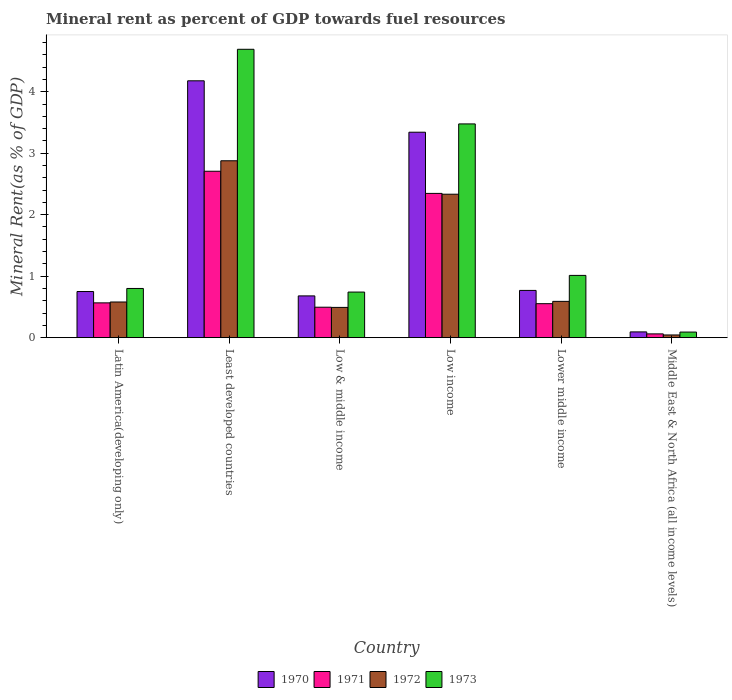How many bars are there on the 1st tick from the right?
Your answer should be very brief. 4. What is the label of the 2nd group of bars from the left?
Ensure brevity in your answer.  Least developed countries. In how many cases, is the number of bars for a given country not equal to the number of legend labels?
Your answer should be very brief. 0. What is the mineral rent in 1970 in Least developed countries?
Provide a succinct answer. 4.18. Across all countries, what is the maximum mineral rent in 1973?
Ensure brevity in your answer.  4.69. Across all countries, what is the minimum mineral rent in 1973?
Give a very brief answer. 0.09. In which country was the mineral rent in 1971 maximum?
Provide a short and direct response. Least developed countries. In which country was the mineral rent in 1973 minimum?
Keep it short and to the point. Middle East & North Africa (all income levels). What is the total mineral rent in 1971 in the graph?
Offer a terse response. 6.73. What is the difference between the mineral rent in 1972 in Low & middle income and that in Lower middle income?
Your answer should be very brief. -0.1. What is the difference between the mineral rent in 1971 in Least developed countries and the mineral rent in 1970 in Low income?
Ensure brevity in your answer.  -0.63. What is the average mineral rent in 1972 per country?
Give a very brief answer. 1.15. What is the difference between the mineral rent of/in 1970 and mineral rent of/in 1971 in Lower middle income?
Give a very brief answer. 0.22. In how many countries, is the mineral rent in 1971 greater than 1.2 %?
Your response must be concise. 2. What is the ratio of the mineral rent in 1972 in Low & middle income to that in Middle East & North Africa (all income levels)?
Offer a very short reply. 11.19. Is the mineral rent in 1973 in Low income less than that in Middle East & North Africa (all income levels)?
Give a very brief answer. No. What is the difference between the highest and the second highest mineral rent in 1970?
Give a very brief answer. -2.57. What is the difference between the highest and the lowest mineral rent in 1970?
Your answer should be compact. 4.08. Are all the bars in the graph horizontal?
Offer a very short reply. No. Are the values on the major ticks of Y-axis written in scientific E-notation?
Your answer should be compact. No. Does the graph contain any zero values?
Your answer should be very brief. No. What is the title of the graph?
Provide a short and direct response. Mineral rent as percent of GDP towards fuel resources. What is the label or title of the X-axis?
Your answer should be compact. Country. What is the label or title of the Y-axis?
Give a very brief answer. Mineral Rent(as % of GDP). What is the Mineral Rent(as % of GDP) of 1970 in Latin America(developing only)?
Give a very brief answer. 0.75. What is the Mineral Rent(as % of GDP) in 1971 in Latin America(developing only)?
Your response must be concise. 0.57. What is the Mineral Rent(as % of GDP) of 1972 in Latin America(developing only)?
Offer a terse response. 0.58. What is the Mineral Rent(as % of GDP) in 1973 in Latin America(developing only)?
Keep it short and to the point. 0.8. What is the Mineral Rent(as % of GDP) in 1970 in Least developed countries?
Give a very brief answer. 4.18. What is the Mineral Rent(as % of GDP) of 1971 in Least developed countries?
Keep it short and to the point. 2.71. What is the Mineral Rent(as % of GDP) of 1972 in Least developed countries?
Offer a terse response. 2.88. What is the Mineral Rent(as % of GDP) of 1973 in Least developed countries?
Make the answer very short. 4.69. What is the Mineral Rent(as % of GDP) of 1970 in Low & middle income?
Offer a terse response. 0.68. What is the Mineral Rent(as % of GDP) of 1971 in Low & middle income?
Your answer should be compact. 0.5. What is the Mineral Rent(as % of GDP) of 1972 in Low & middle income?
Your response must be concise. 0.49. What is the Mineral Rent(as % of GDP) of 1973 in Low & middle income?
Keep it short and to the point. 0.74. What is the Mineral Rent(as % of GDP) in 1970 in Low income?
Make the answer very short. 3.34. What is the Mineral Rent(as % of GDP) of 1971 in Low income?
Keep it short and to the point. 2.35. What is the Mineral Rent(as % of GDP) of 1972 in Low income?
Offer a terse response. 2.33. What is the Mineral Rent(as % of GDP) in 1973 in Low income?
Your answer should be very brief. 3.48. What is the Mineral Rent(as % of GDP) of 1970 in Lower middle income?
Make the answer very short. 0.77. What is the Mineral Rent(as % of GDP) of 1971 in Lower middle income?
Your answer should be compact. 0.55. What is the Mineral Rent(as % of GDP) in 1972 in Lower middle income?
Offer a very short reply. 0.59. What is the Mineral Rent(as % of GDP) in 1973 in Lower middle income?
Make the answer very short. 1.01. What is the Mineral Rent(as % of GDP) of 1970 in Middle East & North Africa (all income levels)?
Ensure brevity in your answer.  0.09. What is the Mineral Rent(as % of GDP) in 1971 in Middle East & North Africa (all income levels)?
Ensure brevity in your answer.  0.06. What is the Mineral Rent(as % of GDP) in 1972 in Middle East & North Africa (all income levels)?
Your answer should be compact. 0.04. What is the Mineral Rent(as % of GDP) of 1973 in Middle East & North Africa (all income levels)?
Keep it short and to the point. 0.09. Across all countries, what is the maximum Mineral Rent(as % of GDP) of 1970?
Offer a very short reply. 4.18. Across all countries, what is the maximum Mineral Rent(as % of GDP) in 1971?
Give a very brief answer. 2.71. Across all countries, what is the maximum Mineral Rent(as % of GDP) in 1972?
Offer a very short reply. 2.88. Across all countries, what is the maximum Mineral Rent(as % of GDP) in 1973?
Your response must be concise. 4.69. Across all countries, what is the minimum Mineral Rent(as % of GDP) of 1970?
Your answer should be very brief. 0.09. Across all countries, what is the minimum Mineral Rent(as % of GDP) of 1971?
Make the answer very short. 0.06. Across all countries, what is the minimum Mineral Rent(as % of GDP) of 1972?
Offer a terse response. 0.04. Across all countries, what is the minimum Mineral Rent(as % of GDP) in 1973?
Your answer should be very brief. 0.09. What is the total Mineral Rent(as % of GDP) of 1970 in the graph?
Make the answer very short. 9.81. What is the total Mineral Rent(as % of GDP) in 1971 in the graph?
Your answer should be compact. 6.73. What is the total Mineral Rent(as % of GDP) in 1972 in the graph?
Your answer should be compact. 6.92. What is the total Mineral Rent(as % of GDP) of 1973 in the graph?
Give a very brief answer. 10.81. What is the difference between the Mineral Rent(as % of GDP) in 1970 in Latin America(developing only) and that in Least developed countries?
Make the answer very short. -3.43. What is the difference between the Mineral Rent(as % of GDP) of 1971 in Latin America(developing only) and that in Least developed countries?
Make the answer very short. -2.14. What is the difference between the Mineral Rent(as % of GDP) of 1972 in Latin America(developing only) and that in Least developed countries?
Make the answer very short. -2.3. What is the difference between the Mineral Rent(as % of GDP) in 1973 in Latin America(developing only) and that in Least developed countries?
Give a very brief answer. -3.89. What is the difference between the Mineral Rent(as % of GDP) of 1970 in Latin America(developing only) and that in Low & middle income?
Ensure brevity in your answer.  0.07. What is the difference between the Mineral Rent(as % of GDP) of 1971 in Latin America(developing only) and that in Low & middle income?
Keep it short and to the point. 0.07. What is the difference between the Mineral Rent(as % of GDP) in 1972 in Latin America(developing only) and that in Low & middle income?
Offer a terse response. 0.09. What is the difference between the Mineral Rent(as % of GDP) of 1973 in Latin America(developing only) and that in Low & middle income?
Give a very brief answer. 0.06. What is the difference between the Mineral Rent(as % of GDP) of 1970 in Latin America(developing only) and that in Low income?
Provide a succinct answer. -2.59. What is the difference between the Mineral Rent(as % of GDP) of 1971 in Latin America(developing only) and that in Low income?
Give a very brief answer. -1.78. What is the difference between the Mineral Rent(as % of GDP) of 1972 in Latin America(developing only) and that in Low income?
Offer a very short reply. -1.75. What is the difference between the Mineral Rent(as % of GDP) of 1973 in Latin America(developing only) and that in Low income?
Provide a short and direct response. -2.68. What is the difference between the Mineral Rent(as % of GDP) in 1970 in Latin America(developing only) and that in Lower middle income?
Your response must be concise. -0.02. What is the difference between the Mineral Rent(as % of GDP) in 1971 in Latin America(developing only) and that in Lower middle income?
Your answer should be compact. 0.01. What is the difference between the Mineral Rent(as % of GDP) in 1972 in Latin America(developing only) and that in Lower middle income?
Provide a short and direct response. -0.01. What is the difference between the Mineral Rent(as % of GDP) of 1973 in Latin America(developing only) and that in Lower middle income?
Make the answer very short. -0.21. What is the difference between the Mineral Rent(as % of GDP) of 1970 in Latin America(developing only) and that in Middle East & North Africa (all income levels)?
Provide a short and direct response. 0.66. What is the difference between the Mineral Rent(as % of GDP) in 1971 in Latin America(developing only) and that in Middle East & North Africa (all income levels)?
Keep it short and to the point. 0.5. What is the difference between the Mineral Rent(as % of GDP) in 1972 in Latin America(developing only) and that in Middle East & North Africa (all income levels)?
Provide a short and direct response. 0.54. What is the difference between the Mineral Rent(as % of GDP) of 1973 in Latin America(developing only) and that in Middle East & North Africa (all income levels)?
Your response must be concise. 0.71. What is the difference between the Mineral Rent(as % of GDP) of 1970 in Least developed countries and that in Low & middle income?
Offer a terse response. 3.5. What is the difference between the Mineral Rent(as % of GDP) in 1971 in Least developed countries and that in Low & middle income?
Offer a very short reply. 2.21. What is the difference between the Mineral Rent(as % of GDP) of 1972 in Least developed countries and that in Low & middle income?
Offer a very short reply. 2.38. What is the difference between the Mineral Rent(as % of GDP) of 1973 in Least developed countries and that in Low & middle income?
Make the answer very short. 3.95. What is the difference between the Mineral Rent(as % of GDP) of 1970 in Least developed countries and that in Low income?
Your answer should be compact. 0.84. What is the difference between the Mineral Rent(as % of GDP) in 1971 in Least developed countries and that in Low income?
Your answer should be compact. 0.36. What is the difference between the Mineral Rent(as % of GDP) of 1972 in Least developed countries and that in Low income?
Provide a succinct answer. 0.54. What is the difference between the Mineral Rent(as % of GDP) in 1973 in Least developed countries and that in Low income?
Provide a short and direct response. 1.21. What is the difference between the Mineral Rent(as % of GDP) in 1970 in Least developed countries and that in Lower middle income?
Ensure brevity in your answer.  3.41. What is the difference between the Mineral Rent(as % of GDP) in 1971 in Least developed countries and that in Lower middle income?
Ensure brevity in your answer.  2.15. What is the difference between the Mineral Rent(as % of GDP) of 1972 in Least developed countries and that in Lower middle income?
Offer a terse response. 2.29. What is the difference between the Mineral Rent(as % of GDP) of 1973 in Least developed countries and that in Lower middle income?
Keep it short and to the point. 3.68. What is the difference between the Mineral Rent(as % of GDP) in 1970 in Least developed countries and that in Middle East & North Africa (all income levels)?
Provide a short and direct response. 4.08. What is the difference between the Mineral Rent(as % of GDP) in 1971 in Least developed countries and that in Middle East & North Africa (all income levels)?
Your answer should be very brief. 2.65. What is the difference between the Mineral Rent(as % of GDP) in 1972 in Least developed countries and that in Middle East & North Africa (all income levels)?
Offer a terse response. 2.83. What is the difference between the Mineral Rent(as % of GDP) of 1973 in Least developed countries and that in Middle East & North Africa (all income levels)?
Make the answer very short. 4.6. What is the difference between the Mineral Rent(as % of GDP) in 1970 in Low & middle income and that in Low income?
Make the answer very short. -2.66. What is the difference between the Mineral Rent(as % of GDP) in 1971 in Low & middle income and that in Low income?
Your response must be concise. -1.85. What is the difference between the Mineral Rent(as % of GDP) of 1972 in Low & middle income and that in Low income?
Your response must be concise. -1.84. What is the difference between the Mineral Rent(as % of GDP) in 1973 in Low & middle income and that in Low income?
Make the answer very short. -2.73. What is the difference between the Mineral Rent(as % of GDP) of 1970 in Low & middle income and that in Lower middle income?
Offer a terse response. -0.09. What is the difference between the Mineral Rent(as % of GDP) in 1971 in Low & middle income and that in Lower middle income?
Ensure brevity in your answer.  -0.06. What is the difference between the Mineral Rent(as % of GDP) in 1972 in Low & middle income and that in Lower middle income?
Your answer should be very brief. -0.1. What is the difference between the Mineral Rent(as % of GDP) of 1973 in Low & middle income and that in Lower middle income?
Make the answer very short. -0.27. What is the difference between the Mineral Rent(as % of GDP) in 1970 in Low & middle income and that in Middle East & North Africa (all income levels)?
Make the answer very short. 0.59. What is the difference between the Mineral Rent(as % of GDP) of 1971 in Low & middle income and that in Middle East & North Africa (all income levels)?
Ensure brevity in your answer.  0.43. What is the difference between the Mineral Rent(as % of GDP) of 1972 in Low & middle income and that in Middle East & North Africa (all income levels)?
Ensure brevity in your answer.  0.45. What is the difference between the Mineral Rent(as % of GDP) in 1973 in Low & middle income and that in Middle East & North Africa (all income levels)?
Your answer should be very brief. 0.65. What is the difference between the Mineral Rent(as % of GDP) of 1970 in Low income and that in Lower middle income?
Your response must be concise. 2.57. What is the difference between the Mineral Rent(as % of GDP) of 1971 in Low income and that in Lower middle income?
Provide a succinct answer. 1.79. What is the difference between the Mineral Rent(as % of GDP) of 1972 in Low income and that in Lower middle income?
Offer a very short reply. 1.74. What is the difference between the Mineral Rent(as % of GDP) in 1973 in Low income and that in Lower middle income?
Make the answer very short. 2.46. What is the difference between the Mineral Rent(as % of GDP) of 1970 in Low income and that in Middle East & North Africa (all income levels)?
Provide a succinct answer. 3.25. What is the difference between the Mineral Rent(as % of GDP) in 1971 in Low income and that in Middle East & North Africa (all income levels)?
Give a very brief answer. 2.28. What is the difference between the Mineral Rent(as % of GDP) in 1972 in Low income and that in Middle East & North Africa (all income levels)?
Your response must be concise. 2.29. What is the difference between the Mineral Rent(as % of GDP) of 1973 in Low income and that in Middle East & North Africa (all income levels)?
Offer a terse response. 3.39. What is the difference between the Mineral Rent(as % of GDP) in 1970 in Lower middle income and that in Middle East & North Africa (all income levels)?
Keep it short and to the point. 0.67. What is the difference between the Mineral Rent(as % of GDP) in 1971 in Lower middle income and that in Middle East & North Africa (all income levels)?
Your response must be concise. 0.49. What is the difference between the Mineral Rent(as % of GDP) of 1972 in Lower middle income and that in Middle East & North Africa (all income levels)?
Offer a very short reply. 0.55. What is the difference between the Mineral Rent(as % of GDP) of 1973 in Lower middle income and that in Middle East & North Africa (all income levels)?
Your response must be concise. 0.92. What is the difference between the Mineral Rent(as % of GDP) in 1970 in Latin America(developing only) and the Mineral Rent(as % of GDP) in 1971 in Least developed countries?
Offer a very short reply. -1.96. What is the difference between the Mineral Rent(as % of GDP) of 1970 in Latin America(developing only) and the Mineral Rent(as % of GDP) of 1972 in Least developed countries?
Keep it short and to the point. -2.13. What is the difference between the Mineral Rent(as % of GDP) in 1970 in Latin America(developing only) and the Mineral Rent(as % of GDP) in 1973 in Least developed countries?
Your answer should be very brief. -3.94. What is the difference between the Mineral Rent(as % of GDP) of 1971 in Latin America(developing only) and the Mineral Rent(as % of GDP) of 1972 in Least developed countries?
Your answer should be compact. -2.31. What is the difference between the Mineral Rent(as % of GDP) in 1971 in Latin America(developing only) and the Mineral Rent(as % of GDP) in 1973 in Least developed countries?
Ensure brevity in your answer.  -4.12. What is the difference between the Mineral Rent(as % of GDP) in 1972 in Latin America(developing only) and the Mineral Rent(as % of GDP) in 1973 in Least developed countries?
Your answer should be compact. -4.11. What is the difference between the Mineral Rent(as % of GDP) in 1970 in Latin America(developing only) and the Mineral Rent(as % of GDP) in 1971 in Low & middle income?
Ensure brevity in your answer.  0.26. What is the difference between the Mineral Rent(as % of GDP) in 1970 in Latin America(developing only) and the Mineral Rent(as % of GDP) in 1972 in Low & middle income?
Offer a terse response. 0.26. What is the difference between the Mineral Rent(as % of GDP) in 1970 in Latin America(developing only) and the Mineral Rent(as % of GDP) in 1973 in Low & middle income?
Provide a short and direct response. 0.01. What is the difference between the Mineral Rent(as % of GDP) in 1971 in Latin America(developing only) and the Mineral Rent(as % of GDP) in 1972 in Low & middle income?
Ensure brevity in your answer.  0.07. What is the difference between the Mineral Rent(as % of GDP) in 1971 in Latin America(developing only) and the Mineral Rent(as % of GDP) in 1973 in Low & middle income?
Ensure brevity in your answer.  -0.18. What is the difference between the Mineral Rent(as % of GDP) in 1972 in Latin America(developing only) and the Mineral Rent(as % of GDP) in 1973 in Low & middle income?
Your answer should be very brief. -0.16. What is the difference between the Mineral Rent(as % of GDP) in 1970 in Latin America(developing only) and the Mineral Rent(as % of GDP) in 1971 in Low income?
Offer a terse response. -1.6. What is the difference between the Mineral Rent(as % of GDP) in 1970 in Latin America(developing only) and the Mineral Rent(as % of GDP) in 1972 in Low income?
Ensure brevity in your answer.  -1.58. What is the difference between the Mineral Rent(as % of GDP) of 1970 in Latin America(developing only) and the Mineral Rent(as % of GDP) of 1973 in Low income?
Offer a terse response. -2.73. What is the difference between the Mineral Rent(as % of GDP) in 1971 in Latin America(developing only) and the Mineral Rent(as % of GDP) in 1972 in Low income?
Make the answer very short. -1.77. What is the difference between the Mineral Rent(as % of GDP) in 1971 in Latin America(developing only) and the Mineral Rent(as % of GDP) in 1973 in Low income?
Give a very brief answer. -2.91. What is the difference between the Mineral Rent(as % of GDP) of 1972 in Latin America(developing only) and the Mineral Rent(as % of GDP) of 1973 in Low income?
Make the answer very short. -2.9. What is the difference between the Mineral Rent(as % of GDP) of 1970 in Latin America(developing only) and the Mineral Rent(as % of GDP) of 1971 in Lower middle income?
Ensure brevity in your answer.  0.2. What is the difference between the Mineral Rent(as % of GDP) in 1970 in Latin America(developing only) and the Mineral Rent(as % of GDP) in 1972 in Lower middle income?
Provide a short and direct response. 0.16. What is the difference between the Mineral Rent(as % of GDP) in 1970 in Latin America(developing only) and the Mineral Rent(as % of GDP) in 1973 in Lower middle income?
Offer a terse response. -0.26. What is the difference between the Mineral Rent(as % of GDP) of 1971 in Latin America(developing only) and the Mineral Rent(as % of GDP) of 1972 in Lower middle income?
Give a very brief answer. -0.02. What is the difference between the Mineral Rent(as % of GDP) of 1971 in Latin America(developing only) and the Mineral Rent(as % of GDP) of 1973 in Lower middle income?
Ensure brevity in your answer.  -0.45. What is the difference between the Mineral Rent(as % of GDP) in 1972 in Latin America(developing only) and the Mineral Rent(as % of GDP) in 1973 in Lower middle income?
Ensure brevity in your answer.  -0.43. What is the difference between the Mineral Rent(as % of GDP) of 1970 in Latin America(developing only) and the Mineral Rent(as % of GDP) of 1971 in Middle East & North Africa (all income levels)?
Your answer should be very brief. 0.69. What is the difference between the Mineral Rent(as % of GDP) in 1970 in Latin America(developing only) and the Mineral Rent(as % of GDP) in 1972 in Middle East & North Africa (all income levels)?
Make the answer very short. 0.71. What is the difference between the Mineral Rent(as % of GDP) in 1970 in Latin America(developing only) and the Mineral Rent(as % of GDP) in 1973 in Middle East & North Africa (all income levels)?
Provide a short and direct response. 0.66. What is the difference between the Mineral Rent(as % of GDP) in 1971 in Latin America(developing only) and the Mineral Rent(as % of GDP) in 1972 in Middle East & North Africa (all income levels)?
Your response must be concise. 0.52. What is the difference between the Mineral Rent(as % of GDP) of 1971 in Latin America(developing only) and the Mineral Rent(as % of GDP) of 1973 in Middle East & North Africa (all income levels)?
Offer a terse response. 0.47. What is the difference between the Mineral Rent(as % of GDP) of 1972 in Latin America(developing only) and the Mineral Rent(as % of GDP) of 1973 in Middle East & North Africa (all income levels)?
Provide a succinct answer. 0.49. What is the difference between the Mineral Rent(as % of GDP) in 1970 in Least developed countries and the Mineral Rent(as % of GDP) in 1971 in Low & middle income?
Make the answer very short. 3.68. What is the difference between the Mineral Rent(as % of GDP) of 1970 in Least developed countries and the Mineral Rent(as % of GDP) of 1972 in Low & middle income?
Provide a succinct answer. 3.69. What is the difference between the Mineral Rent(as % of GDP) of 1970 in Least developed countries and the Mineral Rent(as % of GDP) of 1973 in Low & middle income?
Your answer should be very brief. 3.44. What is the difference between the Mineral Rent(as % of GDP) in 1971 in Least developed countries and the Mineral Rent(as % of GDP) in 1972 in Low & middle income?
Your answer should be very brief. 2.21. What is the difference between the Mineral Rent(as % of GDP) of 1971 in Least developed countries and the Mineral Rent(as % of GDP) of 1973 in Low & middle income?
Keep it short and to the point. 1.97. What is the difference between the Mineral Rent(as % of GDP) in 1972 in Least developed countries and the Mineral Rent(as % of GDP) in 1973 in Low & middle income?
Make the answer very short. 2.14. What is the difference between the Mineral Rent(as % of GDP) in 1970 in Least developed countries and the Mineral Rent(as % of GDP) in 1971 in Low income?
Offer a terse response. 1.83. What is the difference between the Mineral Rent(as % of GDP) of 1970 in Least developed countries and the Mineral Rent(as % of GDP) of 1972 in Low income?
Your answer should be very brief. 1.84. What is the difference between the Mineral Rent(as % of GDP) of 1970 in Least developed countries and the Mineral Rent(as % of GDP) of 1973 in Low income?
Make the answer very short. 0.7. What is the difference between the Mineral Rent(as % of GDP) in 1971 in Least developed countries and the Mineral Rent(as % of GDP) in 1972 in Low income?
Your response must be concise. 0.37. What is the difference between the Mineral Rent(as % of GDP) of 1971 in Least developed countries and the Mineral Rent(as % of GDP) of 1973 in Low income?
Your answer should be very brief. -0.77. What is the difference between the Mineral Rent(as % of GDP) of 1972 in Least developed countries and the Mineral Rent(as % of GDP) of 1973 in Low income?
Your answer should be very brief. -0.6. What is the difference between the Mineral Rent(as % of GDP) in 1970 in Least developed countries and the Mineral Rent(as % of GDP) in 1971 in Lower middle income?
Offer a terse response. 3.62. What is the difference between the Mineral Rent(as % of GDP) of 1970 in Least developed countries and the Mineral Rent(as % of GDP) of 1972 in Lower middle income?
Offer a very short reply. 3.59. What is the difference between the Mineral Rent(as % of GDP) in 1970 in Least developed countries and the Mineral Rent(as % of GDP) in 1973 in Lower middle income?
Make the answer very short. 3.16. What is the difference between the Mineral Rent(as % of GDP) in 1971 in Least developed countries and the Mineral Rent(as % of GDP) in 1972 in Lower middle income?
Keep it short and to the point. 2.12. What is the difference between the Mineral Rent(as % of GDP) of 1971 in Least developed countries and the Mineral Rent(as % of GDP) of 1973 in Lower middle income?
Offer a very short reply. 1.69. What is the difference between the Mineral Rent(as % of GDP) of 1972 in Least developed countries and the Mineral Rent(as % of GDP) of 1973 in Lower middle income?
Provide a succinct answer. 1.86. What is the difference between the Mineral Rent(as % of GDP) of 1970 in Least developed countries and the Mineral Rent(as % of GDP) of 1971 in Middle East & North Africa (all income levels)?
Offer a very short reply. 4.12. What is the difference between the Mineral Rent(as % of GDP) in 1970 in Least developed countries and the Mineral Rent(as % of GDP) in 1972 in Middle East & North Africa (all income levels)?
Provide a succinct answer. 4.13. What is the difference between the Mineral Rent(as % of GDP) in 1970 in Least developed countries and the Mineral Rent(as % of GDP) in 1973 in Middle East & North Africa (all income levels)?
Provide a short and direct response. 4.09. What is the difference between the Mineral Rent(as % of GDP) of 1971 in Least developed countries and the Mineral Rent(as % of GDP) of 1972 in Middle East & North Africa (all income levels)?
Your response must be concise. 2.66. What is the difference between the Mineral Rent(as % of GDP) in 1971 in Least developed countries and the Mineral Rent(as % of GDP) in 1973 in Middle East & North Africa (all income levels)?
Ensure brevity in your answer.  2.62. What is the difference between the Mineral Rent(as % of GDP) in 1972 in Least developed countries and the Mineral Rent(as % of GDP) in 1973 in Middle East & North Africa (all income levels)?
Offer a terse response. 2.79. What is the difference between the Mineral Rent(as % of GDP) in 1970 in Low & middle income and the Mineral Rent(as % of GDP) in 1971 in Low income?
Make the answer very short. -1.67. What is the difference between the Mineral Rent(as % of GDP) of 1970 in Low & middle income and the Mineral Rent(as % of GDP) of 1972 in Low income?
Give a very brief answer. -1.65. What is the difference between the Mineral Rent(as % of GDP) in 1970 in Low & middle income and the Mineral Rent(as % of GDP) in 1973 in Low income?
Ensure brevity in your answer.  -2.8. What is the difference between the Mineral Rent(as % of GDP) in 1971 in Low & middle income and the Mineral Rent(as % of GDP) in 1972 in Low income?
Your response must be concise. -1.84. What is the difference between the Mineral Rent(as % of GDP) in 1971 in Low & middle income and the Mineral Rent(as % of GDP) in 1973 in Low income?
Provide a succinct answer. -2.98. What is the difference between the Mineral Rent(as % of GDP) in 1972 in Low & middle income and the Mineral Rent(as % of GDP) in 1973 in Low income?
Keep it short and to the point. -2.98. What is the difference between the Mineral Rent(as % of GDP) of 1970 in Low & middle income and the Mineral Rent(as % of GDP) of 1971 in Lower middle income?
Provide a succinct answer. 0.13. What is the difference between the Mineral Rent(as % of GDP) in 1970 in Low & middle income and the Mineral Rent(as % of GDP) in 1972 in Lower middle income?
Provide a short and direct response. 0.09. What is the difference between the Mineral Rent(as % of GDP) in 1970 in Low & middle income and the Mineral Rent(as % of GDP) in 1973 in Lower middle income?
Your answer should be very brief. -0.33. What is the difference between the Mineral Rent(as % of GDP) of 1971 in Low & middle income and the Mineral Rent(as % of GDP) of 1972 in Lower middle income?
Offer a terse response. -0.09. What is the difference between the Mineral Rent(as % of GDP) in 1971 in Low & middle income and the Mineral Rent(as % of GDP) in 1973 in Lower middle income?
Make the answer very short. -0.52. What is the difference between the Mineral Rent(as % of GDP) in 1972 in Low & middle income and the Mineral Rent(as % of GDP) in 1973 in Lower middle income?
Ensure brevity in your answer.  -0.52. What is the difference between the Mineral Rent(as % of GDP) in 1970 in Low & middle income and the Mineral Rent(as % of GDP) in 1971 in Middle East & North Africa (all income levels)?
Your response must be concise. 0.62. What is the difference between the Mineral Rent(as % of GDP) in 1970 in Low & middle income and the Mineral Rent(as % of GDP) in 1972 in Middle East & North Africa (all income levels)?
Your answer should be compact. 0.64. What is the difference between the Mineral Rent(as % of GDP) in 1970 in Low & middle income and the Mineral Rent(as % of GDP) in 1973 in Middle East & North Africa (all income levels)?
Ensure brevity in your answer.  0.59. What is the difference between the Mineral Rent(as % of GDP) of 1971 in Low & middle income and the Mineral Rent(as % of GDP) of 1972 in Middle East & North Africa (all income levels)?
Ensure brevity in your answer.  0.45. What is the difference between the Mineral Rent(as % of GDP) of 1971 in Low & middle income and the Mineral Rent(as % of GDP) of 1973 in Middle East & North Africa (all income levels)?
Offer a very short reply. 0.4. What is the difference between the Mineral Rent(as % of GDP) in 1972 in Low & middle income and the Mineral Rent(as % of GDP) in 1973 in Middle East & North Africa (all income levels)?
Provide a short and direct response. 0.4. What is the difference between the Mineral Rent(as % of GDP) of 1970 in Low income and the Mineral Rent(as % of GDP) of 1971 in Lower middle income?
Provide a short and direct response. 2.79. What is the difference between the Mineral Rent(as % of GDP) of 1970 in Low income and the Mineral Rent(as % of GDP) of 1972 in Lower middle income?
Ensure brevity in your answer.  2.75. What is the difference between the Mineral Rent(as % of GDP) of 1970 in Low income and the Mineral Rent(as % of GDP) of 1973 in Lower middle income?
Provide a succinct answer. 2.33. What is the difference between the Mineral Rent(as % of GDP) of 1971 in Low income and the Mineral Rent(as % of GDP) of 1972 in Lower middle income?
Offer a very short reply. 1.76. What is the difference between the Mineral Rent(as % of GDP) in 1971 in Low income and the Mineral Rent(as % of GDP) in 1973 in Lower middle income?
Provide a succinct answer. 1.33. What is the difference between the Mineral Rent(as % of GDP) of 1972 in Low income and the Mineral Rent(as % of GDP) of 1973 in Lower middle income?
Give a very brief answer. 1.32. What is the difference between the Mineral Rent(as % of GDP) of 1970 in Low income and the Mineral Rent(as % of GDP) of 1971 in Middle East & North Africa (all income levels)?
Give a very brief answer. 3.28. What is the difference between the Mineral Rent(as % of GDP) of 1970 in Low income and the Mineral Rent(as % of GDP) of 1972 in Middle East & North Africa (all income levels)?
Your answer should be very brief. 3.3. What is the difference between the Mineral Rent(as % of GDP) of 1970 in Low income and the Mineral Rent(as % of GDP) of 1973 in Middle East & North Africa (all income levels)?
Your response must be concise. 3.25. What is the difference between the Mineral Rent(as % of GDP) in 1971 in Low income and the Mineral Rent(as % of GDP) in 1972 in Middle East & North Africa (all income levels)?
Offer a very short reply. 2.3. What is the difference between the Mineral Rent(as % of GDP) of 1971 in Low income and the Mineral Rent(as % of GDP) of 1973 in Middle East & North Africa (all income levels)?
Your answer should be compact. 2.26. What is the difference between the Mineral Rent(as % of GDP) of 1972 in Low income and the Mineral Rent(as % of GDP) of 1973 in Middle East & North Africa (all income levels)?
Give a very brief answer. 2.24. What is the difference between the Mineral Rent(as % of GDP) in 1970 in Lower middle income and the Mineral Rent(as % of GDP) in 1971 in Middle East & North Africa (all income levels)?
Provide a short and direct response. 0.71. What is the difference between the Mineral Rent(as % of GDP) in 1970 in Lower middle income and the Mineral Rent(as % of GDP) in 1972 in Middle East & North Africa (all income levels)?
Your answer should be compact. 0.72. What is the difference between the Mineral Rent(as % of GDP) of 1970 in Lower middle income and the Mineral Rent(as % of GDP) of 1973 in Middle East & North Africa (all income levels)?
Your response must be concise. 0.68. What is the difference between the Mineral Rent(as % of GDP) in 1971 in Lower middle income and the Mineral Rent(as % of GDP) in 1972 in Middle East & North Africa (all income levels)?
Your answer should be very brief. 0.51. What is the difference between the Mineral Rent(as % of GDP) in 1971 in Lower middle income and the Mineral Rent(as % of GDP) in 1973 in Middle East & North Africa (all income levels)?
Ensure brevity in your answer.  0.46. What is the difference between the Mineral Rent(as % of GDP) in 1972 in Lower middle income and the Mineral Rent(as % of GDP) in 1973 in Middle East & North Africa (all income levels)?
Your answer should be compact. 0.5. What is the average Mineral Rent(as % of GDP) in 1970 per country?
Offer a terse response. 1.64. What is the average Mineral Rent(as % of GDP) in 1971 per country?
Keep it short and to the point. 1.12. What is the average Mineral Rent(as % of GDP) in 1972 per country?
Your answer should be compact. 1.15. What is the average Mineral Rent(as % of GDP) of 1973 per country?
Provide a succinct answer. 1.8. What is the difference between the Mineral Rent(as % of GDP) in 1970 and Mineral Rent(as % of GDP) in 1971 in Latin America(developing only)?
Offer a terse response. 0.18. What is the difference between the Mineral Rent(as % of GDP) of 1970 and Mineral Rent(as % of GDP) of 1972 in Latin America(developing only)?
Ensure brevity in your answer.  0.17. What is the difference between the Mineral Rent(as % of GDP) in 1970 and Mineral Rent(as % of GDP) in 1973 in Latin America(developing only)?
Ensure brevity in your answer.  -0.05. What is the difference between the Mineral Rent(as % of GDP) in 1971 and Mineral Rent(as % of GDP) in 1972 in Latin America(developing only)?
Offer a very short reply. -0.01. What is the difference between the Mineral Rent(as % of GDP) in 1971 and Mineral Rent(as % of GDP) in 1973 in Latin America(developing only)?
Provide a short and direct response. -0.23. What is the difference between the Mineral Rent(as % of GDP) of 1972 and Mineral Rent(as % of GDP) of 1973 in Latin America(developing only)?
Ensure brevity in your answer.  -0.22. What is the difference between the Mineral Rent(as % of GDP) in 1970 and Mineral Rent(as % of GDP) in 1971 in Least developed countries?
Provide a succinct answer. 1.47. What is the difference between the Mineral Rent(as % of GDP) of 1970 and Mineral Rent(as % of GDP) of 1972 in Least developed countries?
Your answer should be compact. 1.3. What is the difference between the Mineral Rent(as % of GDP) in 1970 and Mineral Rent(as % of GDP) in 1973 in Least developed countries?
Offer a terse response. -0.51. What is the difference between the Mineral Rent(as % of GDP) in 1971 and Mineral Rent(as % of GDP) in 1972 in Least developed countries?
Provide a succinct answer. -0.17. What is the difference between the Mineral Rent(as % of GDP) of 1971 and Mineral Rent(as % of GDP) of 1973 in Least developed countries?
Your response must be concise. -1.98. What is the difference between the Mineral Rent(as % of GDP) in 1972 and Mineral Rent(as % of GDP) in 1973 in Least developed countries?
Provide a succinct answer. -1.81. What is the difference between the Mineral Rent(as % of GDP) of 1970 and Mineral Rent(as % of GDP) of 1971 in Low & middle income?
Your answer should be very brief. 0.18. What is the difference between the Mineral Rent(as % of GDP) of 1970 and Mineral Rent(as % of GDP) of 1972 in Low & middle income?
Give a very brief answer. 0.19. What is the difference between the Mineral Rent(as % of GDP) of 1970 and Mineral Rent(as % of GDP) of 1973 in Low & middle income?
Provide a succinct answer. -0.06. What is the difference between the Mineral Rent(as % of GDP) in 1971 and Mineral Rent(as % of GDP) in 1972 in Low & middle income?
Provide a short and direct response. 0. What is the difference between the Mineral Rent(as % of GDP) of 1971 and Mineral Rent(as % of GDP) of 1973 in Low & middle income?
Your answer should be very brief. -0.25. What is the difference between the Mineral Rent(as % of GDP) in 1972 and Mineral Rent(as % of GDP) in 1973 in Low & middle income?
Your answer should be very brief. -0.25. What is the difference between the Mineral Rent(as % of GDP) in 1970 and Mineral Rent(as % of GDP) in 1971 in Low income?
Your answer should be compact. 1. What is the difference between the Mineral Rent(as % of GDP) of 1970 and Mineral Rent(as % of GDP) of 1972 in Low income?
Offer a terse response. 1.01. What is the difference between the Mineral Rent(as % of GDP) of 1970 and Mineral Rent(as % of GDP) of 1973 in Low income?
Give a very brief answer. -0.14. What is the difference between the Mineral Rent(as % of GDP) of 1971 and Mineral Rent(as % of GDP) of 1972 in Low income?
Your answer should be compact. 0.01. What is the difference between the Mineral Rent(as % of GDP) in 1971 and Mineral Rent(as % of GDP) in 1973 in Low income?
Keep it short and to the point. -1.13. What is the difference between the Mineral Rent(as % of GDP) of 1972 and Mineral Rent(as % of GDP) of 1973 in Low income?
Provide a succinct answer. -1.14. What is the difference between the Mineral Rent(as % of GDP) in 1970 and Mineral Rent(as % of GDP) in 1971 in Lower middle income?
Provide a short and direct response. 0.22. What is the difference between the Mineral Rent(as % of GDP) of 1970 and Mineral Rent(as % of GDP) of 1972 in Lower middle income?
Your answer should be very brief. 0.18. What is the difference between the Mineral Rent(as % of GDP) in 1970 and Mineral Rent(as % of GDP) in 1973 in Lower middle income?
Keep it short and to the point. -0.24. What is the difference between the Mineral Rent(as % of GDP) in 1971 and Mineral Rent(as % of GDP) in 1972 in Lower middle income?
Your response must be concise. -0.04. What is the difference between the Mineral Rent(as % of GDP) of 1971 and Mineral Rent(as % of GDP) of 1973 in Lower middle income?
Offer a very short reply. -0.46. What is the difference between the Mineral Rent(as % of GDP) of 1972 and Mineral Rent(as % of GDP) of 1973 in Lower middle income?
Provide a succinct answer. -0.42. What is the difference between the Mineral Rent(as % of GDP) in 1970 and Mineral Rent(as % of GDP) in 1971 in Middle East & North Africa (all income levels)?
Give a very brief answer. 0.03. What is the difference between the Mineral Rent(as % of GDP) in 1970 and Mineral Rent(as % of GDP) in 1972 in Middle East & North Africa (all income levels)?
Make the answer very short. 0.05. What is the difference between the Mineral Rent(as % of GDP) in 1970 and Mineral Rent(as % of GDP) in 1973 in Middle East & North Africa (all income levels)?
Make the answer very short. 0. What is the difference between the Mineral Rent(as % of GDP) in 1971 and Mineral Rent(as % of GDP) in 1972 in Middle East & North Africa (all income levels)?
Keep it short and to the point. 0.02. What is the difference between the Mineral Rent(as % of GDP) of 1971 and Mineral Rent(as % of GDP) of 1973 in Middle East & North Africa (all income levels)?
Provide a succinct answer. -0.03. What is the difference between the Mineral Rent(as % of GDP) in 1972 and Mineral Rent(as % of GDP) in 1973 in Middle East & North Africa (all income levels)?
Your answer should be very brief. -0.05. What is the ratio of the Mineral Rent(as % of GDP) of 1970 in Latin America(developing only) to that in Least developed countries?
Your answer should be very brief. 0.18. What is the ratio of the Mineral Rent(as % of GDP) of 1971 in Latin America(developing only) to that in Least developed countries?
Offer a terse response. 0.21. What is the ratio of the Mineral Rent(as % of GDP) of 1972 in Latin America(developing only) to that in Least developed countries?
Your answer should be very brief. 0.2. What is the ratio of the Mineral Rent(as % of GDP) of 1973 in Latin America(developing only) to that in Least developed countries?
Offer a very short reply. 0.17. What is the ratio of the Mineral Rent(as % of GDP) in 1970 in Latin America(developing only) to that in Low & middle income?
Make the answer very short. 1.1. What is the ratio of the Mineral Rent(as % of GDP) of 1971 in Latin America(developing only) to that in Low & middle income?
Provide a short and direct response. 1.14. What is the ratio of the Mineral Rent(as % of GDP) of 1972 in Latin America(developing only) to that in Low & middle income?
Make the answer very short. 1.18. What is the ratio of the Mineral Rent(as % of GDP) of 1973 in Latin America(developing only) to that in Low & middle income?
Make the answer very short. 1.08. What is the ratio of the Mineral Rent(as % of GDP) in 1970 in Latin America(developing only) to that in Low income?
Your answer should be compact. 0.22. What is the ratio of the Mineral Rent(as % of GDP) in 1971 in Latin America(developing only) to that in Low income?
Keep it short and to the point. 0.24. What is the ratio of the Mineral Rent(as % of GDP) in 1972 in Latin America(developing only) to that in Low income?
Provide a succinct answer. 0.25. What is the ratio of the Mineral Rent(as % of GDP) in 1973 in Latin America(developing only) to that in Low income?
Offer a terse response. 0.23. What is the ratio of the Mineral Rent(as % of GDP) of 1970 in Latin America(developing only) to that in Lower middle income?
Your answer should be very brief. 0.98. What is the ratio of the Mineral Rent(as % of GDP) of 1971 in Latin America(developing only) to that in Lower middle income?
Offer a terse response. 1.02. What is the ratio of the Mineral Rent(as % of GDP) in 1972 in Latin America(developing only) to that in Lower middle income?
Provide a succinct answer. 0.98. What is the ratio of the Mineral Rent(as % of GDP) in 1973 in Latin America(developing only) to that in Lower middle income?
Offer a terse response. 0.79. What is the ratio of the Mineral Rent(as % of GDP) of 1970 in Latin America(developing only) to that in Middle East & North Africa (all income levels)?
Provide a short and direct response. 8.01. What is the ratio of the Mineral Rent(as % of GDP) in 1971 in Latin America(developing only) to that in Middle East & North Africa (all income levels)?
Provide a short and direct response. 9.2. What is the ratio of the Mineral Rent(as % of GDP) of 1972 in Latin America(developing only) to that in Middle East & North Africa (all income levels)?
Ensure brevity in your answer.  13.19. What is the ratio of the Mineral Rent(as % of GDP) of 1973 in Latin America(developing only) to that in Middle East & North Africa (all income levels)?
Provide a succinct answer. 8.79. What is the ratio of the Mineral Rent(as % of GDP) of 1970 in Least developed countries to that in Low & middle income?
Your response must be concise. 6.15. What is the ratio of the Mineral Rent(as % of GDP) of 1971 in Least developed countries to that in Low & middle income?
Your answer should be compact. 5.46. What is the ratio of the Mineral Rent(as % of GDP) in 1972 in Least developed countries to that in Low & middle income?
Give a very brief answer. 5.85. What is the ratio of the Mineral Rent(as % of GDP) of 1973 in Least developed countries to that in Low & middle income?
Offer a very short reply. 6.33. What is the ratio of the Mineral Rent(as % of GDP) in 1970 in Least developed countries to that in Low income?
Your answer should be very brief. 1.25. What is the ratio of the Mineral Rent(as % of GDP) of 1971 in Least developed countries to that in Low income?
Provide a succinct answer. 1.15. What is the ratio of the Mineral Rent(as % of GDP) in 1972 in Least developed countries to that in Low income?
Offer a very short reply. 1.23. What is the ratio of the Mineral Rent(as % of GDP) in 1973 in Least developed countries to that in Low income?
Offer a terse response. 1.35. What is the ratio of the Mineral Rent(as % of GDP) in 1970 in Least developed countries to that in Lower middle income?
Make the answer very short. 5.44. What is the ratio of the Mineral Rent(as % of GDP) in 1971 in Least developed countries to that in Lower middle income?
Offer a very short reply. 4.9. What is the ratio of the Mineral Rent(as % of GDP) of 1972 in Least developed countries to that in Lower middle income?
Make the answer very short. 4.87. What is the ratio of the Mineral Rent(as % of GDP) in 1973 in Least developed countries to that in Lower middle income?
Give a very brief answer. 4.63. What is the ratio of the Mineral Rent(as % of GDP) of 1970 in Least developed countries to that in Middle East & North Africa (all income levels)?
Ensure brevity in your answer.  44.61. What is the ratio of the Mineral Rent(as % of GDP) of 1971 in Least developed countries to that in Middle East & North Africa (all income levels)?
Your answer should be very brief. 43.99. What is the ratio of the Mineral Rent(as % of GDP) of 1972 in Least developed countries to that in Middle East & North Africa (all income levels)?
Give a very brief answer. 65.42. What is the ratio of the Mineral Rent(as % of GDP) of 1973 in Least developed countries to that in Middle East & North Africa (all income levels)?
Offer a terse response. 51.51. What is the ratio of the Mineral Rent(as % of GDP) in 1970 in Low & middle income to that in Low income?
Give a very brief answer. 0.2. What is the ratio of the Mineral Rent(as % of GDP) of 1971 in Low & middle income to that in Low income?
Provide a succinct answer. 0.21. What is the ratio of the Mineral Rent(as % of GDP) of 1972 in Low & middle income to that in Low income?
Your answer should be compact. 0.21. What is the ratio of the Mineral Rent(as % of GDP) of 1973 in Low & middle income to that in Low income?
Ensure brevity in your answer.  0.21. What is the ratio of the Mineral Rent(as % of GDP) in 1970 in Low & middle income to that in Lower middle income?
Provide a short and direct response. 0.88. What is the ratio of the Mineral Rent(as % of GDP) in 1971 in Low & middle income to that in Lower middle income?
Your answer should be very brief. 0.9. What is the ratio of the Mineral Rent(as % of GDP) in 1972 in Low & middle income to that in Lower middle income?
Ensure brevity in your answer.  0.83. What is the ratio of the Mineral Rent(as % of GDP) of 1973 in Low & middle income to that in Lower middle income?
Your answer should be compact. 0.73. What is the ratio of the Mineral Rent(as % of GDP) in 1970 in Low & middle income to that in Middle East & North Africa (all income levels)?
Your response must be concise. 7.25. What is the ratio of the Mineral Rent(as % of GDP) of 1971 in Low & middle income to that in Middle East & North Africa (all income levels)?
Give a very brief answer. 8.05. What is the ratio of the Mineral Rent(as % of GDP) in 1972 in Low & middle income to that in Middle East & North Africa (all income levels)?
Ensure brevity in your answer.  11.19. What is the ratio of the Mineral Rent(as % of GDP) in 1973 in Low & middle income to that in Middle East & North Africa (all income levels)?
Provide a succinct answer. 8.14. What is the ratio of the Mineral Rent(as % of GDP) of 1970 in Low income to that in Lower middle income?
Keep it short and to the point. 4.35. What is the ratio of the Mineral Rent(as % of GDP) in 1971 in Low income to that in Lower middle income?
Ensure brevity in your answer.  4.25. What is the ratio of the Mineral Rent(as % of GDP) in 1972 in Low income to that in Lower middle income?
Make the answer very short. 3.95. What is the ratio of the Mineral Rent(as % of GDP) of 1973 in Low income to that in Lower middle income?
Make the answer very short. 3.43. What is the ratio of the Mineral Rent(as % of GDP) in 1970 in Low income to that in Middle East & North Africa (all income levels)?
Give a very brief answer. 35.68. What is the ratio of the Mineral Rent(as % of GDP) in 1971 in Low income to that in Middle East & North Africa (all income levels)?
Your answer should be very brief. 38.13. What is the ratio of the Mineral Rent(as % of GDP) in 1972 in Low income to that in Middle East & North Africa (all income levels)?
Make the answer very short. 53.05. What is the ratio of the Mineral Rent(as % of GDP) in 1973 in Low income to that in Middle East & North Africa (all income levels)?
Provide a succinct answer. 38.18. What is the ratio of the Mineral Rent(as % of GDP) of 1970 in Lower middle income to that in Middle East & North Africa (all income levels)?
Offer a very short reply. 8.21. What is the ratio of the Mineral Rent(as % of GDP) in 1971 in Lower middle income to that in Middle East & North Africa (all income levels)?
Provide a succinct answer. 8.98. What is the ratio of the Mineral Rent(as % of GDP) of 1972 in Lower middle income to that in Middle East & North Africa (all income levels)?
Keep it short and to the point. 13.42. What is the ratio of the Mineral Rent(as % of GDP) of 1973 in Lower middle income to that in Middle East & North Africa (all income levels)?
Ensure brevity in your answer.  11.12. What is the difference between the highest and the second highest Mineral Rent(as % of GDP) of 1970?
Ensure brevity in your answer.  0.84. What is the difference between the highest and the second highest Mineral Rent(as % of GDP) of 1971?
Keep it short and to the point. 0.36. What is the difference between the highest and the second highest Mineral Rent(as % of GDP) in 1972?
Offer a very short reply. 0.54. What is the difference between the highest and the second highest Mineral Rent(as % of GDP) in 1973?
Give a very brief answer. 1.21. What is the difference between the highest and the lowest Mineral Rent(as % of GDP) of 1970?
Make the answer very short. 4.08. What is the difference between the highest and the lowest Mineral Rent(as % of GDP) of 1971?
Give a very brief answer. 2.65. What is the difference between the highest and the lowest Mineral Rent(as % of GDP) in 1972?
Your answer should be very brief. 2.83. What is the difference between the highest and the lowest Mineral Rent(as % of GDP) of 1973?
Provide a short and direct response. 4.6. 